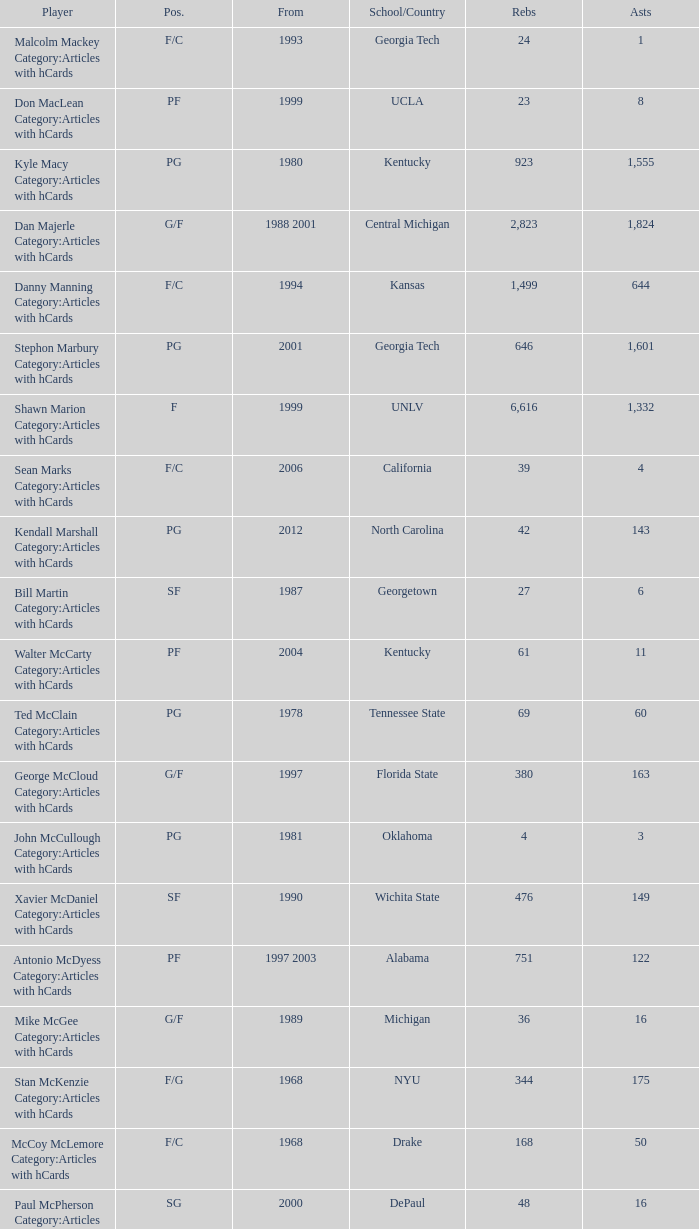What position does the player from arkansas play? C. 